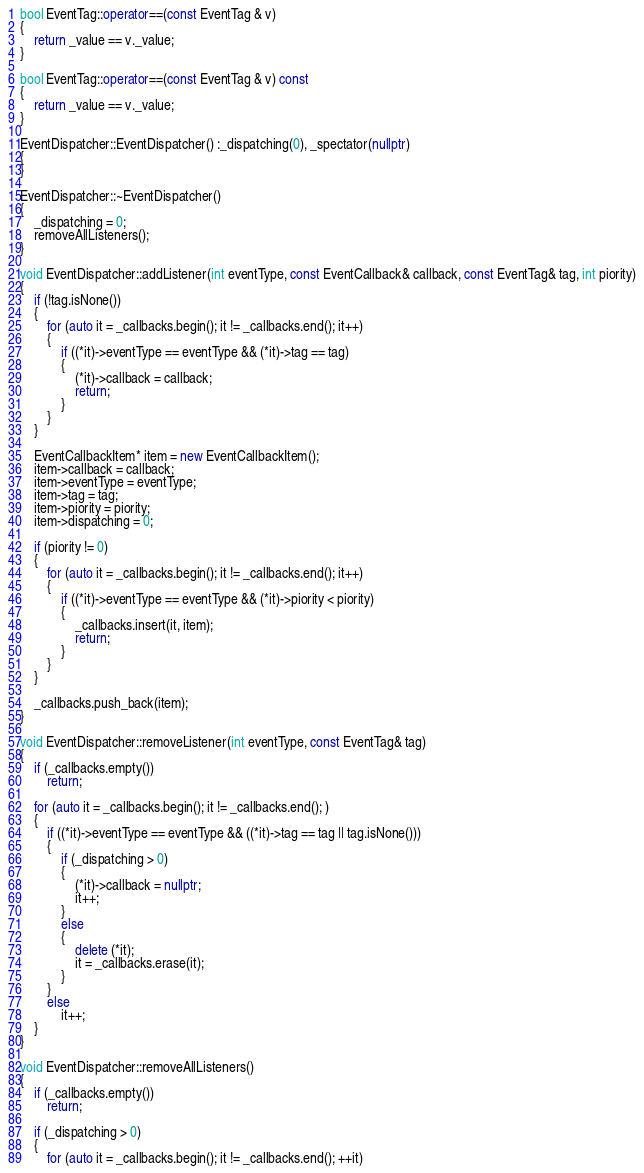Convert code to text. <code><loc_0><loc_0><loc_500><loc_500><_C++_>bool EventTag::operator==(const EventTag & v)
{
    return _value == v._value;
}

bool EventTag::operator==(const EventTag & v) const
{
    return _value == v._value;
}

EventDispatcher::EventDispatcher() :_dispatching(0), _spectator(nullptr)
{
}

EventDispatcher::~EventDispatcher()
{
    _dispatching = 0;
    removeAllListeners();
}

void EventDispatcher::addListener(int eventType, const EventCallback& callback, const EventTag& tag, int piority)
{
    if (!tag.isNone())
    {
        for (auto it = _callbacks.begin(); it != _callbacks.end(); it++)
        {
            if ((*it)->eventType == eventType && (*it)->tag == tag)
            {
                (*it)->callback = callback;
                return;
            }
        }
    }

    EventCallbackItem* item = new EventCallbackItem();
    item->callback = callback;
    item->eventType = eventType;
    item->tag = tag;
    item->piority = piority;
    item->dispatching = 0;

    if (piority != 0)
    {
        for (auto it = _callbacks.begin(); it != _callbacks.end(); it++)
        {
            if ((*it)->eventType == eventType && (*it)->piority < piority)
            {
                _callbacks.insert(it, item);
                return;
            }
        }
    }

    _callbacks.push_back(item);
}

void EventDispatcher::removeListener(int eventType, const EventTag& tag)
{
    if (_callbacks.empty())
        return;

    for (auto it = _callbacks.begin(); it != _callbacks.end(); )
    {
        if ((*it)->eventType == eventType && ((*it)->tag == tag || tag.isNone()))
        {
            if (_dispatching > 0)
            {
                (*it)->callback = nullptr;
                it++;
            }
            else
            {
                delete (*it);
                it = _callbacks.erase(it);
            }
        }
        else
            it++;
    }
}

void EventDispatcher::removeAllListeners()
{
    if (_callbacks.empty())
        return;

    if (_dispatching > 0)
    {
        for (auto it = _callbacks.begin(); it != _callbacks.end(); ++it)</code> 